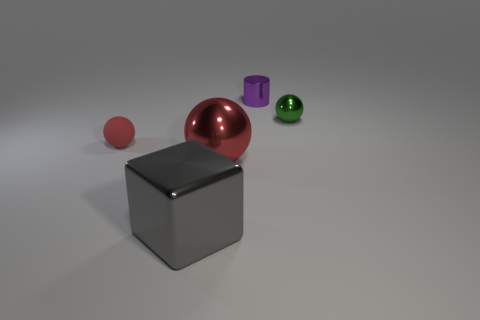Is there any other thing that has the same material as the tiny red ball?
Your answer should be compact. No. There is a small ball in front of the green metallic sphere; what material is it?
Provide a short and direct response. Rubber. There is a rubber object; is it the same shape as the big object that is to the right of the gray metal thing?
Give a very brief answer. Yes. There is a red object left of the red sphere that is on the right side of the large metal block; how many small things are in front of it?
Ensure brevity in your answer.  0. What is the color of the matte object that is the same shape as the tiny green metal object?
Your answer should be very brief. Red. Are there any other things that have the same shape as the big gray thing?
Offer a very short reply. No. What number of cylinders are either gray things or large red metallic things?
Ensure brevity in your answer.  0. The tiny red object has what shape?
Make the answer very short. Sphere. There is a metal cylinder; are there any purple objects behind it?
Provide a succinct answer. No. Do the gray thing and the tiny ball to the left of the green ball have the same material?
Make the answer very short. No. 